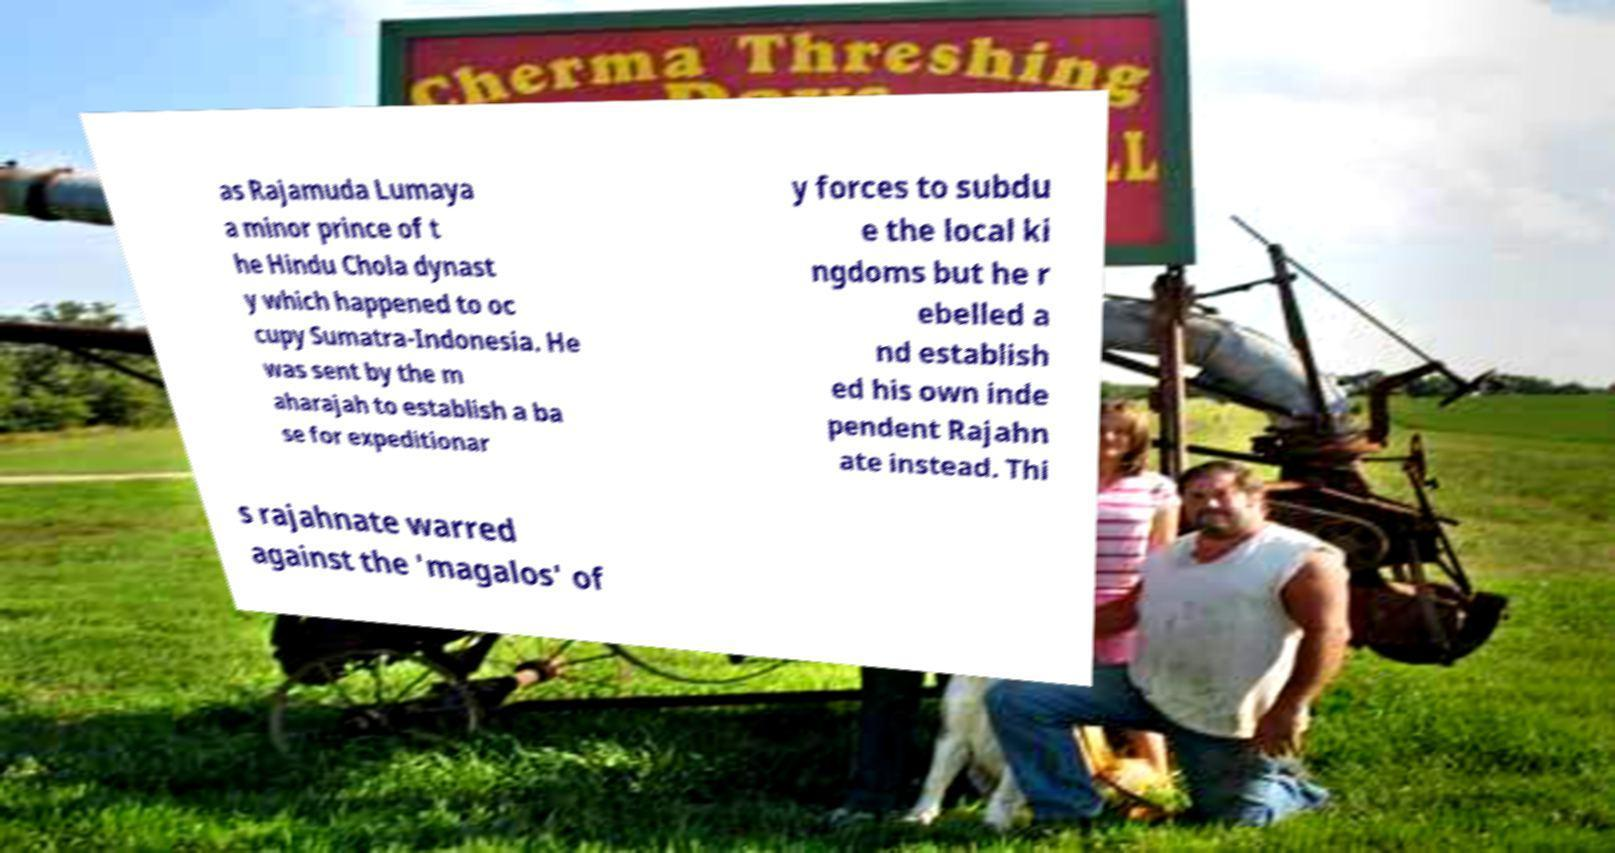Can you accurately transcribe the text from the provided image for me? as Rajamuda Lumaya a minor prince of t he Hindu Chola dynast y which happened to oc cupy Sumatra-Indonesia. He was sent by the m aharajah to establish a ba se for expeditionar y forces to subdu e the local ki ngdoms but he r ebelled a nd establish ed his own inde pendent Rajahn ate instead. Thi s rajahnate warred against the 'magalos' of 